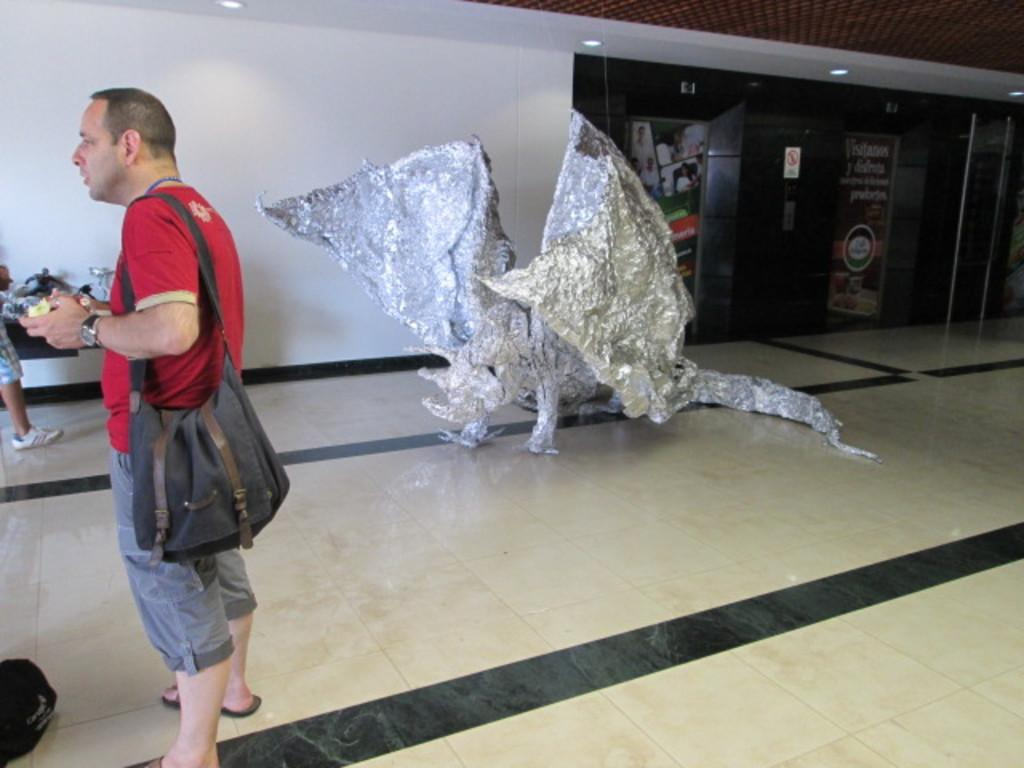What type of sculpture is in the image? There is an aluminium foil sculpture in the image. Where is the sculpture located in relation to the man? The sculpture is on the floor or on the left side in relation to the man. What is the man holding in the image? The man is holding a bag. What is the man's posture in the image? The man is standing. What type of error can be seen in the image? There is no error present in the image. Can you tell me how many basins are visible in the image? There are no basins present in the image. 